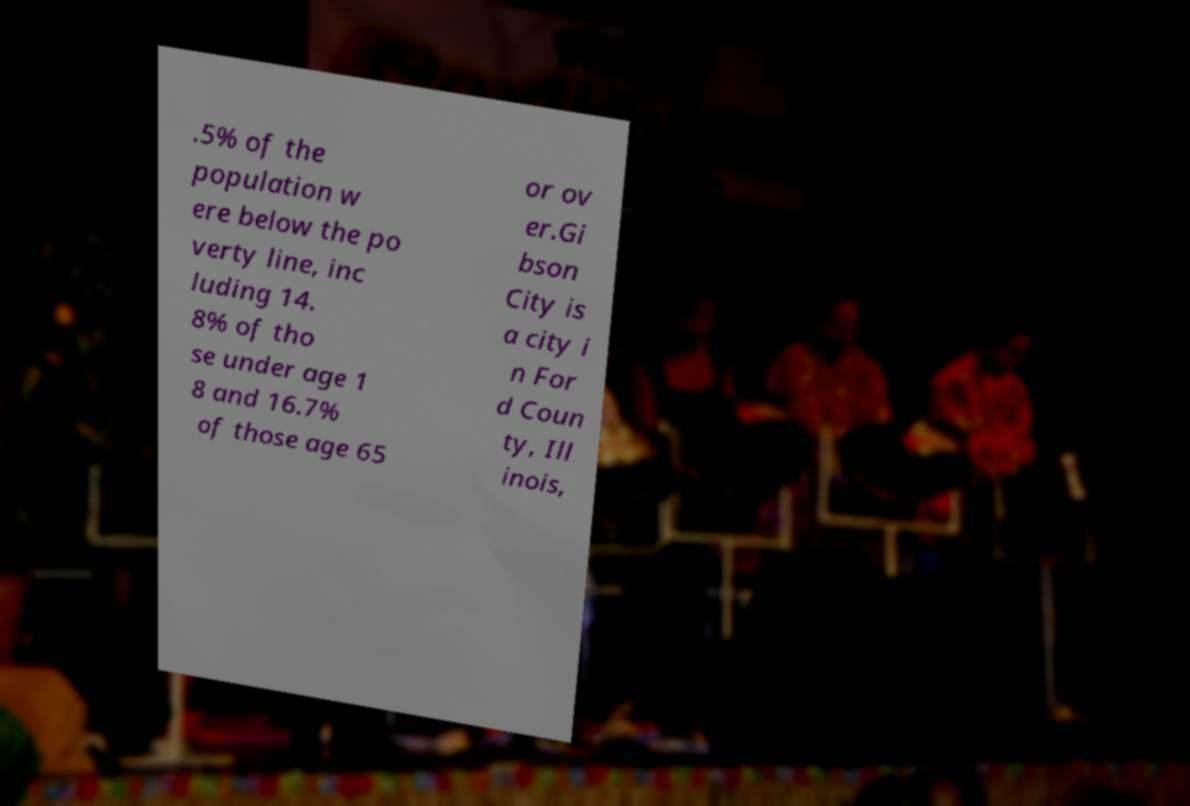I need the written content from this picture converted into text. Can you do that? .5% of the population w ere below the po verty line, inc luding 14. 8% of tho se under age 1 8 and 16.7% of those age 65 or ov er.Gi bson City is a city i n For d Coun ty, Ill inois, 